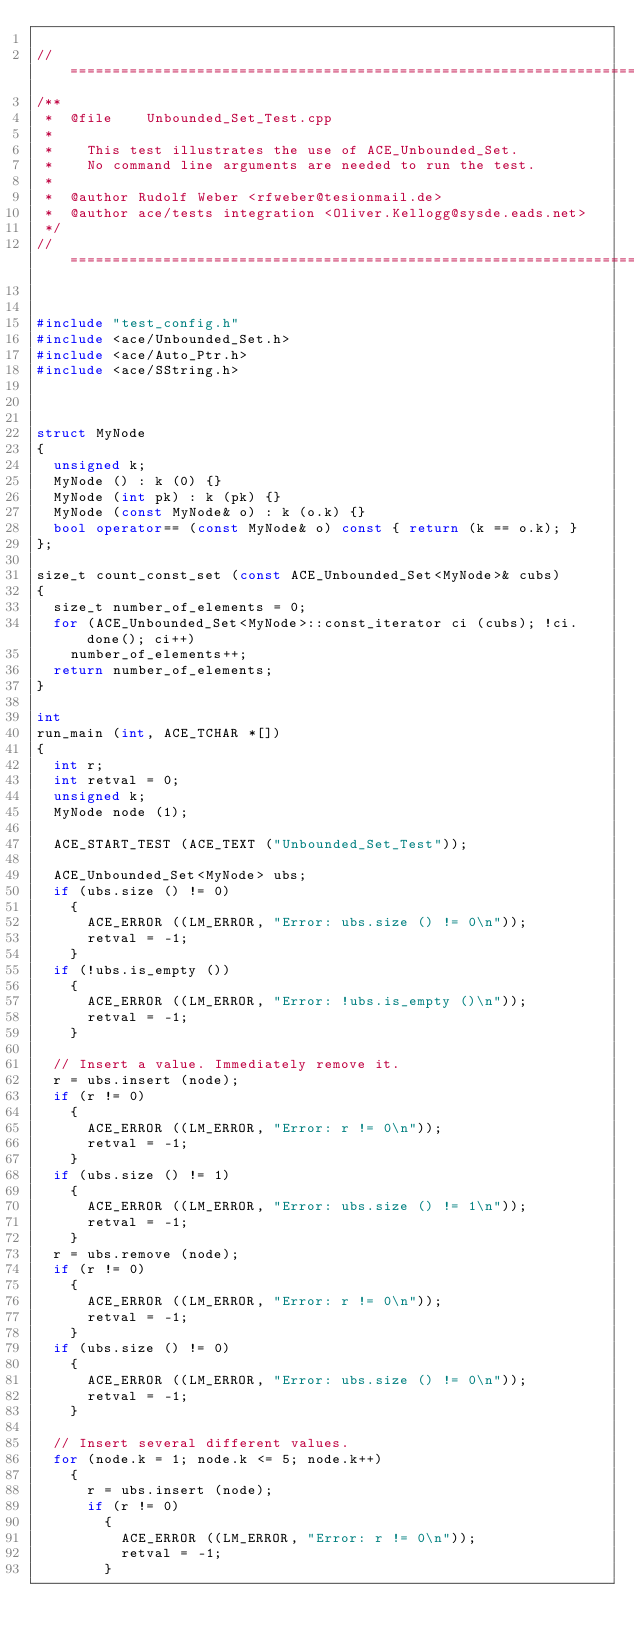Convert code to text. <code><loc_0><loc_0><loc_500><loc_500><_C++_>
//=============================================================================
/**
 *  @file    Unbounded_Set_Test.cpp
 *
 *    This test illustrates the use of ACE_Unbounded_Set.
 *    No command line arguments are needed to run the test.
 *
 *  @author Rudolf Weber <rfweber@tesionmail.de>
 *  @author ace/tests integration <Oliver.Kellogg@sysde.eads.net>
 */
//=============================================================================


#include "test_config.h"
#include <ace/Unbounded_Set.h>
#include <ace/Auto_Ptr.h>
#include <ace/SString.h>



struct MyNode
{
  unsigned k;
  MyNode () : k (0) {}
  MyNode (int pk) : k (pk) {}
  MyNode (const MyNode& o) : k (o.k) {}
  bool operator== (const MyNode& o) const { return (k == o.k); }
};

size_t count_const_set (const ACE_Unbounded_Set<MyNode>& cubs)
{
  size_t number_of_elements = 0;
  for (ACE_Unbounded_Set<MyNode>::const_iterator ci (cubs); !ci.done(); ci++)
    number_of_elements++;
  return number_of_elements;
}

int
run_main (int, ACE_TCHAR *[])
{
  int r;
  int retval = 0;
  unsigned k;
  MyNode node (1);

  ACE_START_TEST (ACE_TEXT ("Unbounded_Set_Test"));

  ACE_Unbounded_Set<MyNode> ubs;
  if (ubs.size () != 0)
    {
      ACE_ERROR ((LM_ERROR, "Error: ubs.size () != 0\n"));
      retval = -1;
    }
  if (!ubs.is_empty ())
    {
      ACE_ERROR ((LM_ERROR, "Error: !ubs.is_empty ()\n"));
      retval = -1;
    }

  // Insert a value. Immediately remove it.
  r = ubs.insert (node);
  if (r != 0)
    {
      ACE_ERROR ((LM_ERROR, "Error: r != 0\n"));
      retval = -1;
    }
  if (ubs.size () != 1)
    {
      ACE_ERROR ((LM_ERROR, "Error: ubs.size () != 1\n"));
      retval = -1;
    }
  r = ubs.remove (node);
  if (r != 0)
    {
      ACE_ERROR ((LM_ERROR, "Error: r != 0\n"));
      retval = -1;
    }
  if (ubs.size () != 0)
    {
      ACE_ERROR ((LM_ERROR, "Error: ubs.size () != 0\n"));
      retval = -1;
    }

  // Insert several different values.
  for (node.k = 1; node.k <= 5; node.k++)
    {
      r = ubs.insert (node);
      if (r != 0)
        {
          ACE_ERROR ((LM_ERROR, "Error: r != 0\n"));
          retval = -1;
        }</code> 